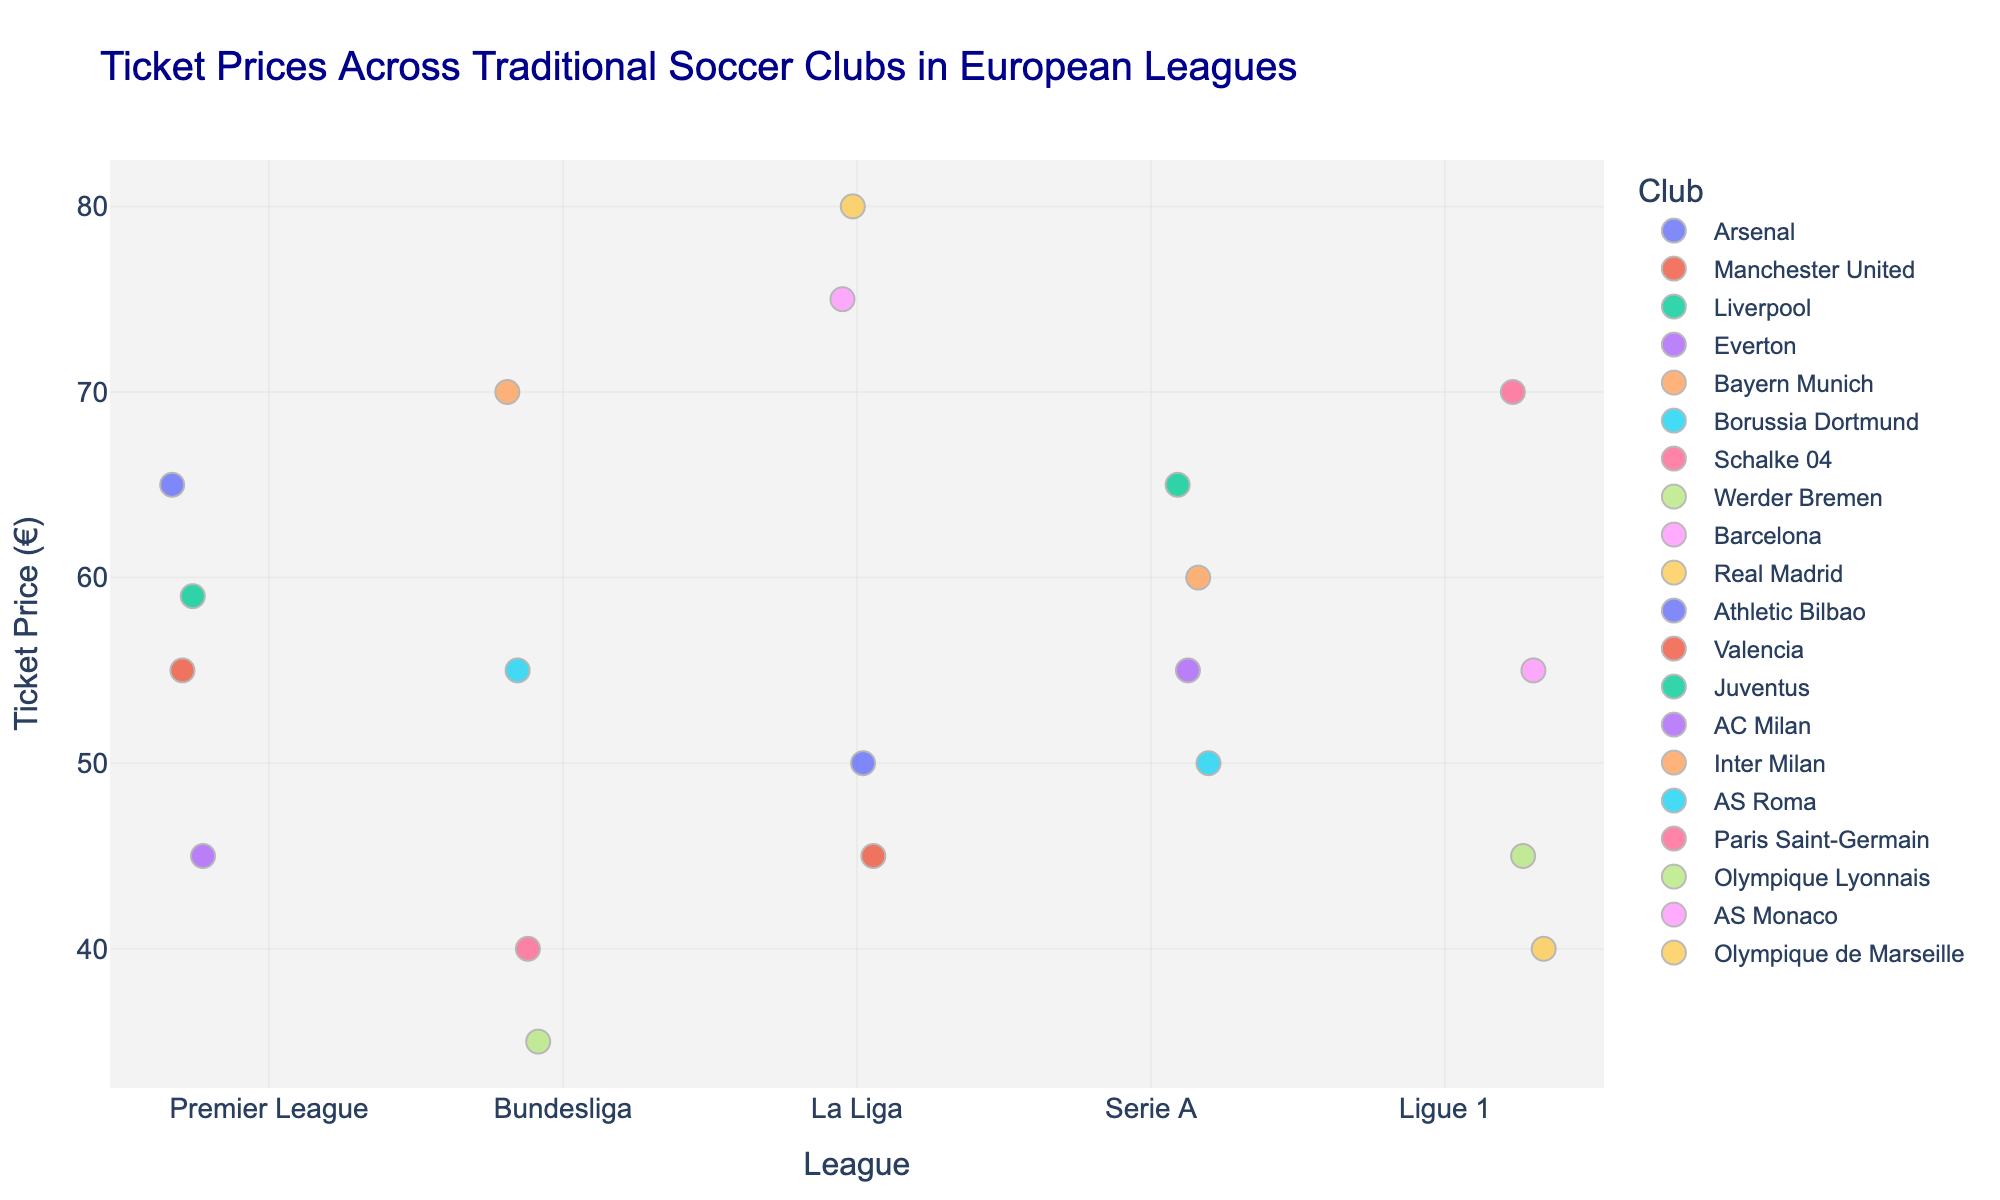What's the average ticket price for Premier League clubs? To find the average ticket price, sum all ticket prices for Premier League clubs (65, 55, 59, 45), which equals 224, and then divide by the number of clubs (4). Thus, average = 224 / 4.
Answer: 56 Which club in La Liga has the highest ticket price? Check the data points for La Liga clubs and identify the highest value. Real Madrid has the highest ticket price at 80€.
Answer: Real Madrid How does the ticket price of Borussia Dortmund compare to that of Bayern Munich? Compare the ticket prices of Borussia Dortmund (55) and Bayern Munich (70). Borussia Dortmund has a lower ticket price.
Answer: Borussia Dortmund has a lower ticket price What's the range of ticket prices for Ligue 1 clubs? Identify the minimum and maximum ticket prices among Ligue 1 clubs. The prices are 40, 45, 55, and 70, so the range is 70 - 40.
Answer: 30 Among Serie A clubs, which one has the lowest ticket price? Check the ticket prices for Serie A clubs and identify the lowest value. AS Roma has a ticket price of 50€, which is the lowest.
Answer: AS Roma What's the difference in ticket price between AC Milan and Inter Milan? Subtract the ticket price of AC Milan (55) from Inter Milan (60), giving 60 - 55.
Answer: 5 Which league overall has the highest average ticket price? Calculate the average ticket price for each league and compare them. Compare the means of different leagues:
Premier League: (65 + 55 + 59 + 45)/4 = 56.
Bundesliga: (70 + 55 + 40 + 35)/4 = 50.
La Liga: (75 + 80 + 50 + 45)/4 = 62.5.
Serie A: (65 + 55 + 60 + 50)/4 = 57.5.
Ligue 1: (70 + 45 + 55 + 40)/4 = 52.5.
La Liga has the highest average.
Answer: La Liga Are there any clubs with the same ticket price in different leagues? Check the ticket prices across all clubs and find any two that match exactly. Arsenal in Premier League and Juventus in Serie A both have a ticket price of 65€, and Borussia Dortmund in Bundesliga and Manchester United in Premier League both have ticket prices of 55€.
Answer: Yes, Arsenal and Juventus with 65€, Borussia Dortmund and Manchester United with 55€ How does the ticket price variation within Serie A compare to that of the Bundesliga? Calculate the range for both leagues.
Serie A: Highest is Juventus at 65€ and lowest is AS Roma at 50€, so the range is 65 - 50 = 15.
Bundesliga: Highest is Bayern Munich at 70€ and lowest is Werder Bremen at 35€, so the range is 70 - 35 = 35.
Bundesliga has a wider variation.
Answer: Bundesliga has a wider variation Which club has the lowest ticket price overall and in which league does it belong? Identify the lowest ticket price among all clubs. Werder Bremen has the lowest ticket price at 35€ and belongs to the Bundesliga.
Answer: Werder Bremen, Bundesliga 